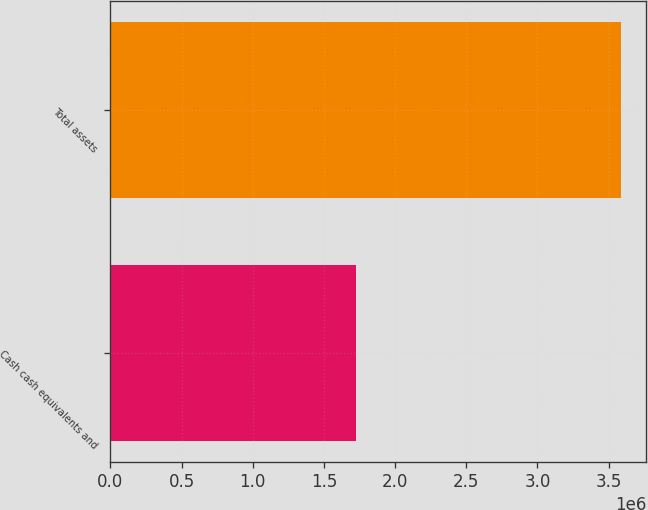<chart> <loc_0><loc_0><loc_500><loc_500><bar_chart><fcel>Cash cash equivalents and<fcel>Total assets<nl><fcel>1.72823e+06<fcel>3.58592e+06<nl></chart> 